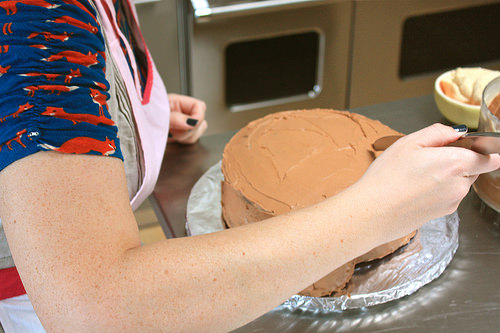<image>
Is there a woman next to the cake? Yes. The woman is positioned adjacent to the cake, located nearby in the same general area. 